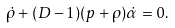<formula> <loc_0><loc_0><loc_500><loc_500>\dot { \rho } + ( D - 1 ) ( p + \rho ) \dot { \alpha } = 0 .</formula> 